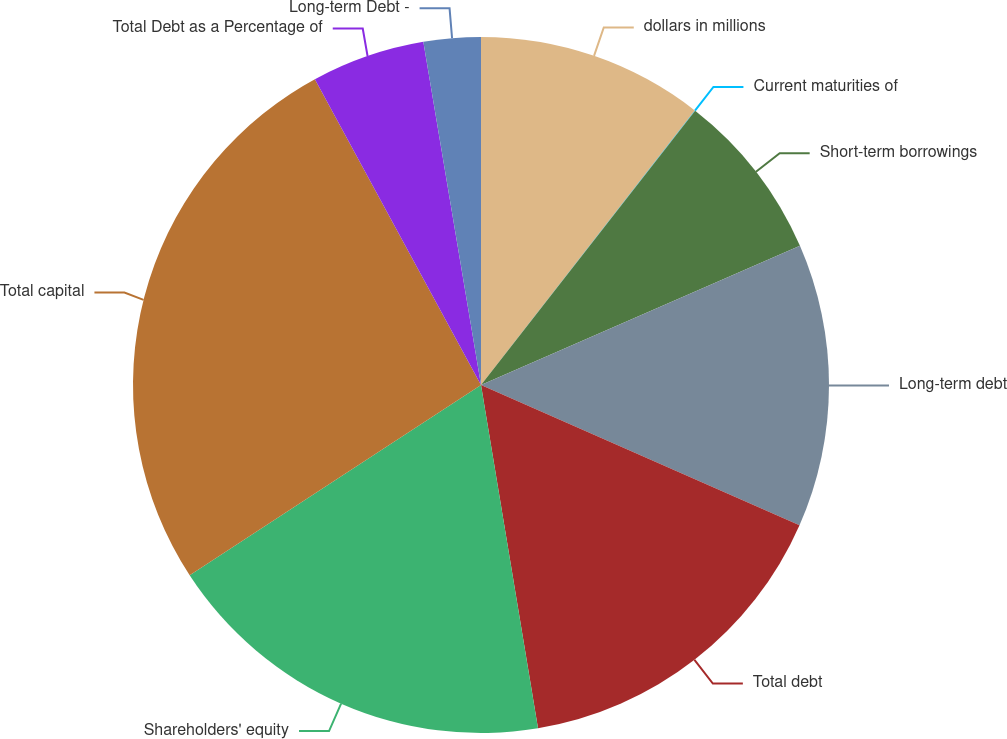Convert chart. <chart><loc_0><loc_0><loc_500><loc_500><pie_chart><fcel>dollars in millions<fcel>Current maturities of<fcel>Short-term borrowings<fcel>Long-term debt<fcel>Total debt<fcel>Shareholders' equity<fcel>Total capital<fcel>Total Debt as a Percentage of<fcel>Long-term Debt -<nl><fcel>10.53%<fcel>0.02%<fcel>7.9%<fcel>13.15%<fcel>15.78%<fcel>18.41%<fcel>26.29%<fcel>5.27%<fcel>2.65%<nl></chart> 